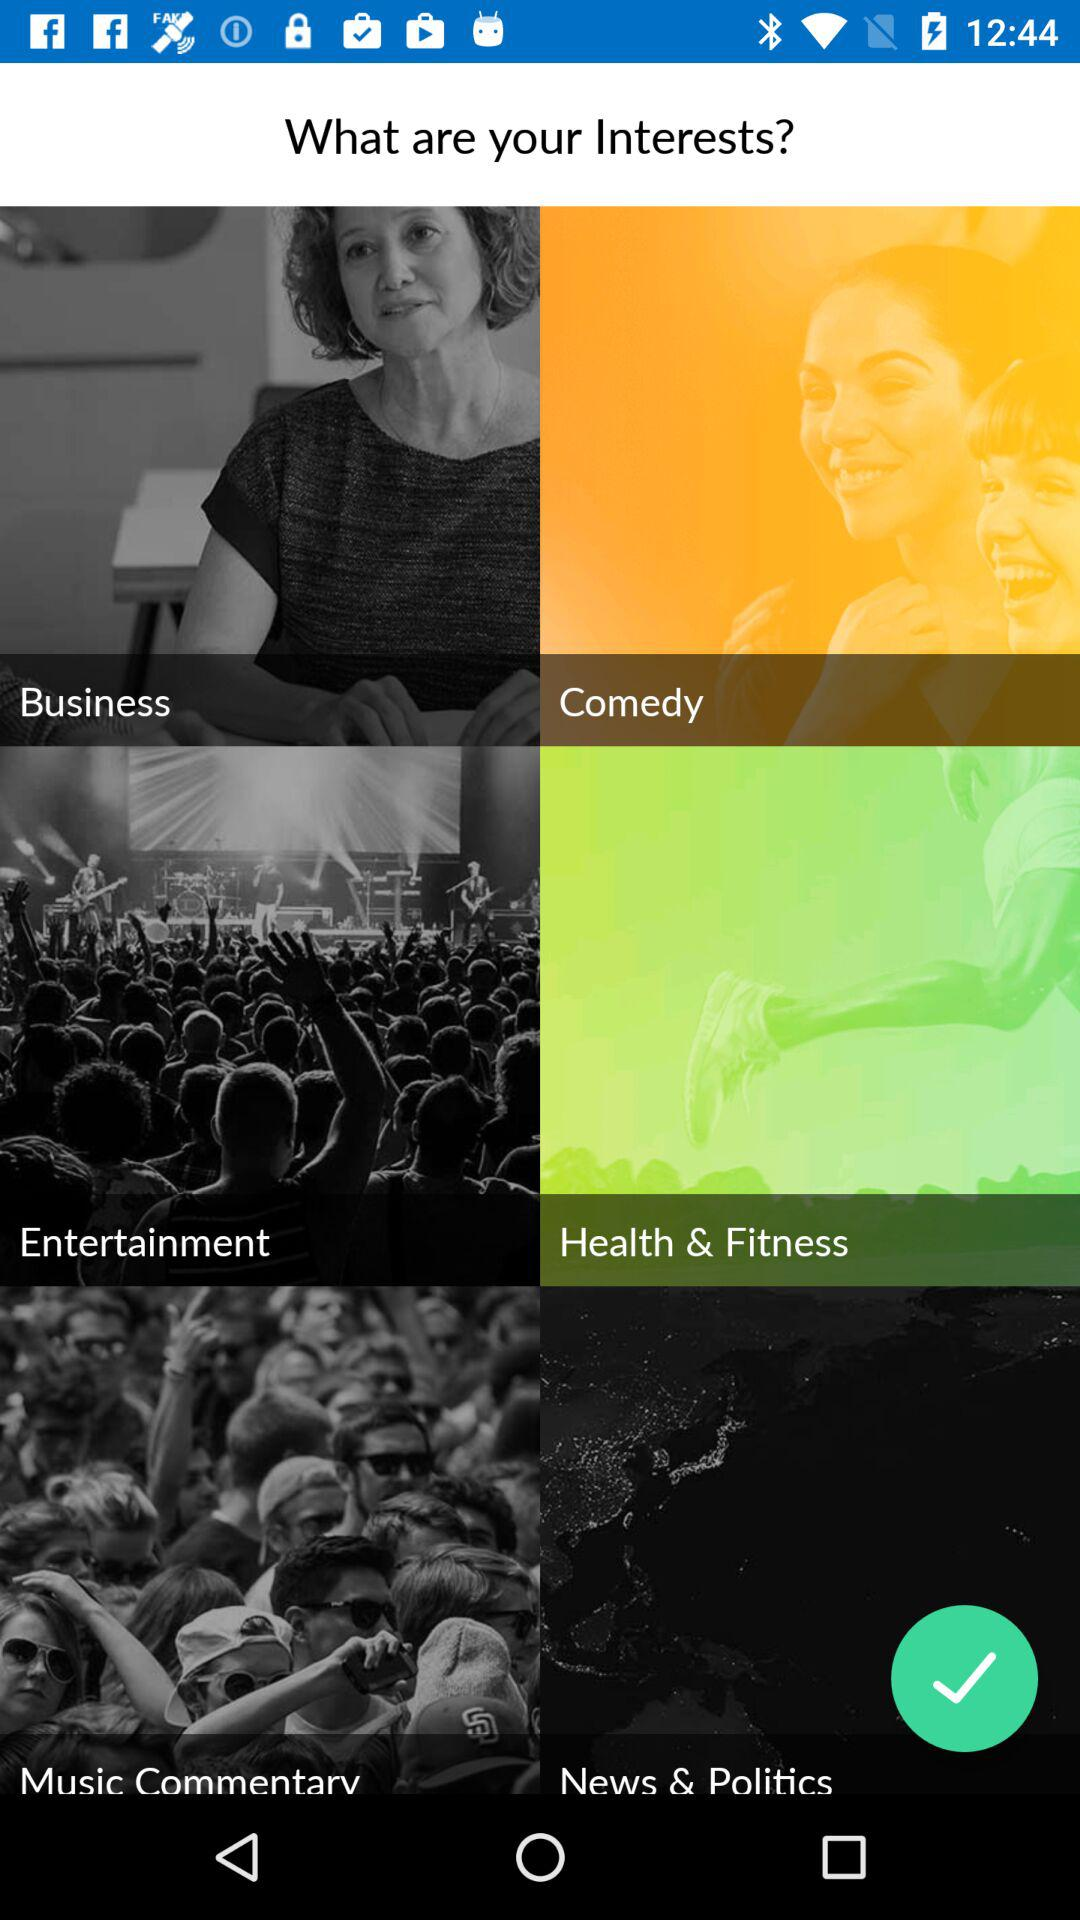How many interests are there in total?
Answer the question using a single word or phrase. 6 